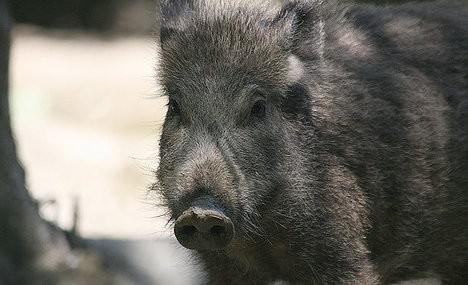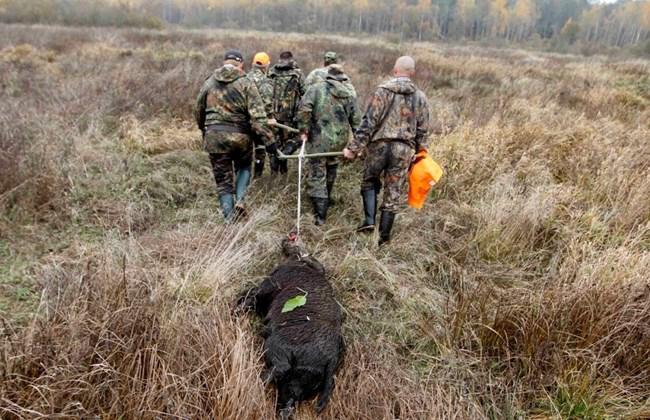The first image is the image on the left, the second image is the image on the right. Analyze the images presented: Is the assertion "In one of the images there are two or more brown striped pigs." valid? Answer yes or no. No. The first image is the image on the left, the second image is the image on the right. Considering the images on both sides, is "There is a single boar in the left image." valid? Answer yes or no. Yes. 